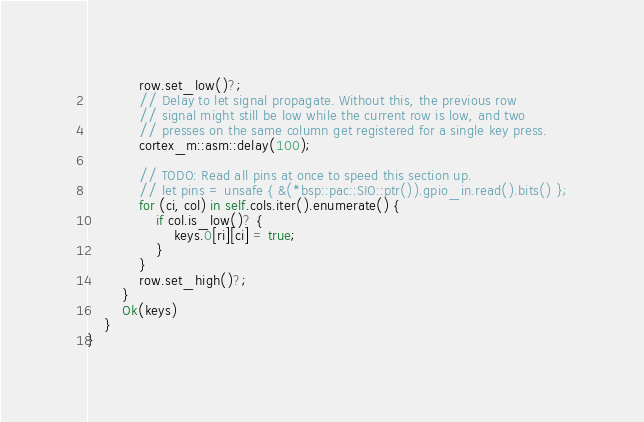Convert code to text. <code><loc_0><loc_0><loc_500><loc_500><_Rust_>            row.set_low()?;
            // Delay to let signal propagate. Without this, the previous row
            // signal might still be low while the current row is low, and two
            // presses on the same column get registered for a single key press.
            cortex_m::asm::delay(100);

            // TODO: Read all pins at once to speed this section up.
            // let pins = unsafe { &(*bsp::pac::SIO::ptr()).gpio_in.read().bits() };
            for (ci, col) in self.cols.iter().enumerate() {
                if col.is_low()? {
                    keys.0[ri][ci] = true;
                }
            }
            row.set_high()?;
        }
        Ok(keys)
    }
}
</code> 